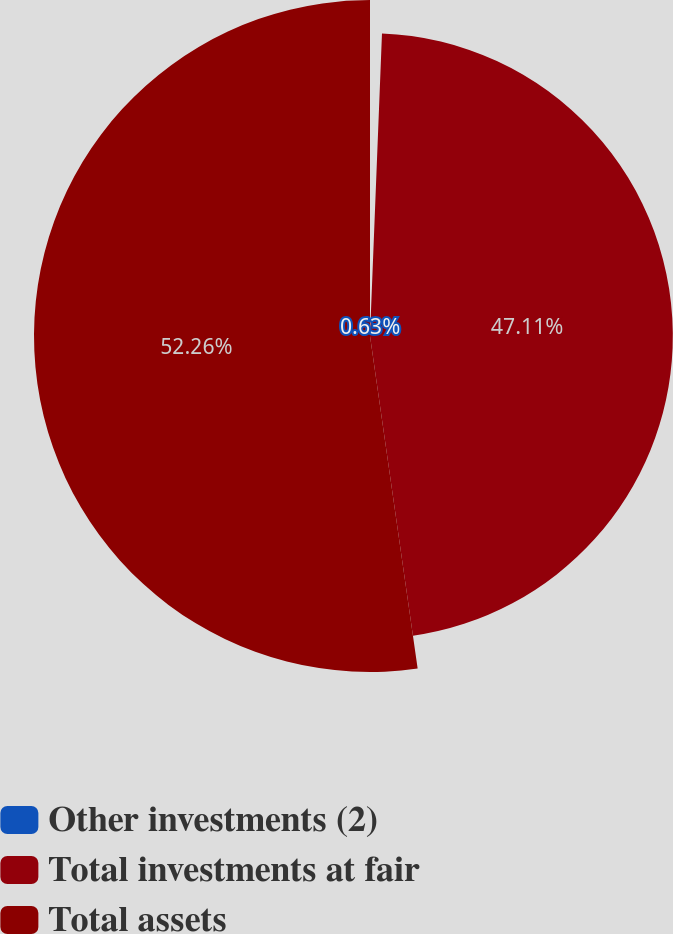Convert chart to OTSL. <chart><loc_0><loc_0><loc_500><loc_500><pie_chart><fcel>Other investments (2)<fcel>Total investments at fair<fcel>Total assets<nl><fcel>0.63%<fcel>47.11%<fcel>52.27%<nl></chart> 